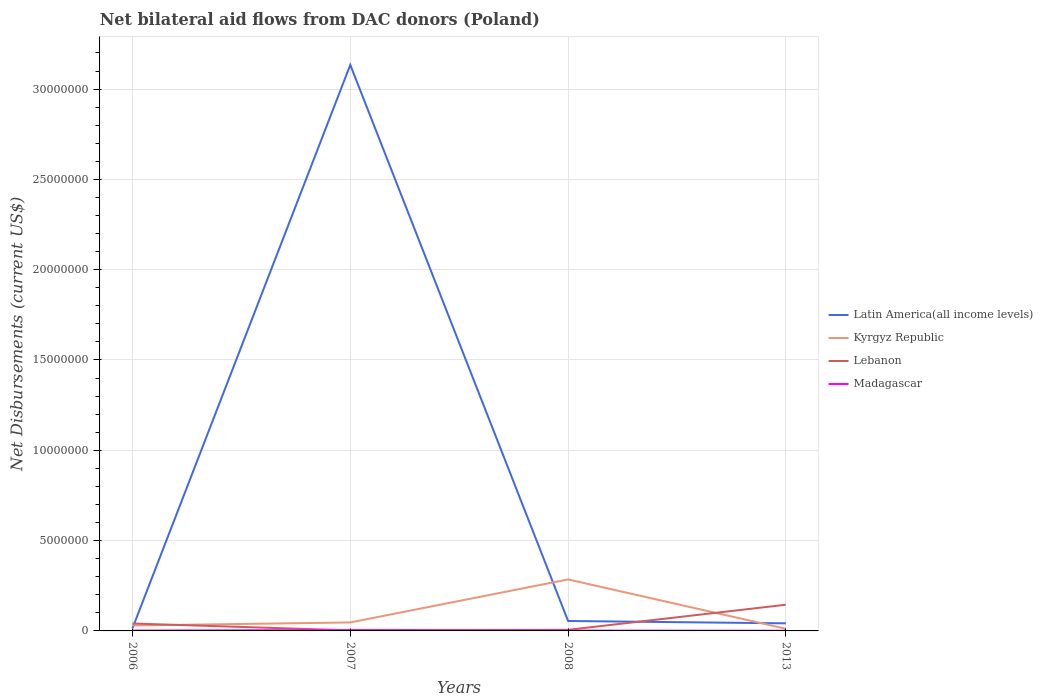Does the line corresponding to Latin America(all income levels) intersect with the line corresponding to Madagascar?
Offer a terse response. No. Across all years, what is the maximum net bilateral aid flows in Lebanon?
Your answer should be compact. 3.00e+04. In which year was the net bilateral aid flows in Latin America(all income levels) maximum?
Ensure brevity in your answer.  2006. What is the total net bilateral aid flows in Madagascar in the graph?
Your answer should be very brief. -3.00e+04. What is the difference between the highest and the second highest net bilateral aid flows in Kyrgyz Republic?
Your answer should be very brief. 2.73e+06. What is the difference between the highest and the lowest net bilateral aid flows in Madagascar?
Your answer should be very brief. 1. How many years are there in the graph?
Offer a terse response. 4. What is the difference between two consecutive major ticks on the Y-axis?
Offer a very short reply. 5.00e+06. Does the graph contain grids?
Provide a succinct answer. Yes. Where does the legend appear in the graph?
Keep it short and to the point. Center right. How many legend labels are there?
Ensure brevity in your answer.  4. How are the legend labels stacked?
Provide a short and direct response. Vertical. What is the title of the graph?
Make the answer very short. Net bilateral aid flows from DAC donors (Poland). Does "Ireland" appear as one of the legend labels in the graph?
Keep it short and to the point. No. What is the label or title of the Y-axis?
Make the answer very short. Net Disbursements (current US$). What is the Net Disbursements (current US$) of Latin America(all income levels) in 2006?
Ensure brevity in your answer.  1.50e+05. What is the Net Disbursements (current US$) in Kyrgyz Republic in 2006?
Your response must be concise. 3.00e+05. What is the Net Disbursements (current US$) in Lebanon in 2006?
Offer a very short reply. 4.10e+05. What is the Net Disbursements (current US$) in Latin America(all income levels) in 2007?
Ensure brevity in your answer.  3.13e+07. What is the Net Disbursements (current US$) of Lebanon in 2007?
Your response must be concise. 3.00e+04. What is the Net Disbursements (current US$) in Madagascar in 2007?
Provide a succinct answer. 5.00e+04. What is the Net Disbursements (current US$) of Kyrgyz Republic in 2008?
Your answer should be compact. 2.85e+06. What is the Net Disbursements (current US$) of Lebanon in 2008?
Keep it short and to the point. 6.00e+04. What is the Net Disbursements (current US$) in Madagascar in 2008?
Provide a short and direct response. 2.00e+04. What is the Net Disbursements (current US$) in Kyrgyz Republic in 2013?
Give a very brief answer. 1.20e+05. What is the Net Disbursements (current US$) in Lebanon in 2013?
Offer a very short reply. 1.45e+06. Across all years, what is the maximum Net Disbursements (current US$) of Latin America(all income levels)?
Offer a very short reply. 3.13e+07. Across all years, what is the maximum Net Disbursements (current US$) in Kyrgyz Republic?
Ensure brevity in your answer.  2.85e+06. Across all years, what is the maximum Net Disbursements (current US$) of Lebanon?
Your response must be concise. 1.45e+06. Across all years, what is the maximum Net Disbursements (current US$) in Madagascar?
Your answer should be very brief. 5.00e+04. Across all years, what is the minimum Net Disbursements (current US$) of Latin America(all income levels)?
Your response must be concise. 1.50e+05. Across all years, what is the minimum Net Disbursements (current US$) of Madagascar?
Keep it short and to the point. 10000. What is the total Net Disbursements (current US$) of Latin America(all income levels) in the graph?
Offer a very short reply. 3.25e+07. What is the total Net Disbursements (current US$) in Kyrgyz Republic in the graph?
Make the answer very short. 3.74e+06. What is the total Net Disbursements (current US$) of Lebanon in the graph?
Offer a very short reply. 1.95e+06. What is the total Net Disbursements (current US$) of Madagascar in the graph?
Your answer should be compact. 1.00e+05. What is the difference between the Net Disbursements (current US$) in Latin America(all income levels) in 2006 and that in 2007?
Make the answer very short. -3.12e+07. What is the difference between the Net Disbursements (current US$) in Lebanon in 2006 and that in 2007?
Keep it short and to the point. 3.80e+05. What is the difference between the Net Disbursements (current US$) in Latin America(all income levels) in 2006 and that in 2008?
Offer a terse response. -4.00e+05. What is the difference between the Net Disbursements (current US$) of Kyrgyz Republic in 2006 and that in 2008?
Give a very brief answer. -2.55e+06. What is the difference between the Net Disbursements (current US$) of Madagascar in 2006 and that in 2008?
Your response must be concise. 0. What is the difference between the Net Disbursements (current US$) of Latin America(all income levels) in 2006 and that in 2013?
Make the answer very short. -2.70e+05. What is the difference between the Net Disbursements (current US$) of Lebanon in 2006 and that in 2013?
Provide a short and direct response. -1.04e+06. What is the difference between the Net Disbursements (current US$) in Madagascar in 2006 and that in 2013?
Provide a short and direct response. 10000. What is the difference between the Net Disbursements (current US$) of Latin America(all income levels) in 2007 and that in 2008?
Offer a terse response. 3.08e+07. What is the difference between the Net Disbursements (current US$) in Kyrgyz Republic in 2007 and that in 2008?
Provide a succinct answer. -2.38e+06. What is the difference between the Net Disbursements (current US$) in Lebanon in 2007 and that in 2008?
Make the answer very short. -3.00e+04. What is the difference between the Net Disbursements (current US$) of Latin America(all income levels) in 2007 and that in 2013?
Make the answer very short. 3.09e+07. What is the difference between the Net Disbursements (current US$) of Kyrgyz Republic in 2007 and that in 2013?
Ensure brevity in your answer.  3.50e+05. What is the difference between the Net Disbursements (current US$) in Lebanon in 2007 and that in 2013?
Your response must be concise. -1.42e+06. What is the difference between the Net Disbursements (current US$) of Kyrgyz Republic in 2008 and that in 2013?
Offer a terse response. 2.73e+06. What is the difference between the Net Disbursements (current US$) in Lebanon in 2008 and that in 2013?
Provide a succinct answer. -1.39e+06. What is the difference between the Net Disbursements (current US$) of Madagascar in 2008 and that in 2013?
Provide a short and direct response. 10000. What is the difference between the Net Disbursements (current US$) of Latin America(all income levels) in 2006 and the Net Disbursements (current US$) of Kyrgyz Republic in 2007?
Ensure brevity in your answer.  -3.20e+05. What is the difference between the Net Disbursements (current US$) in Latin America(all income levels) in 2006 and the Net Disbursements (current US$) in Madagascar in 2007?
Provide a short and direct response. 1.00e+05. What is the difference between the Net Disbursements (current US$) of Kyrgyz Republic in 2006 and the Net Disbursements (current US$) of Lebanon in 2007?
Offer a terse response. 2.70e+05. What is the difference between the Net Disbursements (current US$) in Kyrgyz Republic in 2006 and the Net Disbursements (current US$) in Madagascar in 2007?
Make the answer very short. 2.50e+05. What is the difference between the Net Disbursements (current US$) in Lebanon in 2006 and the Net Disbursements (current US$) in Madagascar in 2007?
Your response must be concise. 3.60e+05. What is the difference between the Net Disbursements (current US$) in Latin America(all income levels) in 2006 and the Net Disbursements (current US$) in Kyrgyz Republic in 2008?
Your response must be concise. -2.70e+06. What is the difference between the Net Disbursements (current US$) in Latin America(all income levels) in 2006 and the Net Disbursements (current US$) in Lebanon in 2008?
Keep it short and to the point. 9.00e+04. What is the difference between the Net Disbursements (current US$) of Latin America(all income levels) in 2006 and the Net Disbursements (current US$) of Madagascar in 2008?
Offer a very short reply. 1.30e+05. What is the difference between the Net Disbursements (current US$) of Kyrgyz Republic in 2006 and the Net Disbursements (current US$) of Madagascar in 2008?
Give a very brief answer. 2.80e+05. What is the difference between the Net Disbursements (current US$) in Lebanon in 2006 and the Net Disbursements (current US$) in Madagascar in 2008?
Your answer should be compact. 3.90e+05. What is the difference between the Net Disbursements (current US$) in Latin America(all income levels) in 2006 and the Net Disbursements (current US$) in Kyrgyz Republic in 2013?
Offer a very short reply. 3.00e+04. What is the difference between the Net Disbursements (current US$) in Latin America(all income levels) in 2006 and the Net Disbursements (current US$) in Lebanon in 2013?
Provide a short and direct response. -1.30e+06. What is the difference between the Net Disbursements (current US$) of Latin America(all income levels) in 2006 and the Net Disbursements (current US$) of Madagascar in 2013?
Offer a very short reply. 1.40e+05. What is the difference between the Net Disbursements (current US$) in Kyrgyz Republic in 2006 and the Net Disbursements (current US$) in Lebanon in 2013?
Provide a short and direct response. -1.15e+06. What is the difference between the Net Disbursements (current US$) of Kyrgyz Republic in 2006 and the Net Disbursements (current US$) of Madagascar in 2013?
Your answer should be compact. 2.90e+05. What is the difference between the Net Disbursements (current US$) in Lebanon in 2006 and the Net Disbursements (current US$) in Madagascar in 2013?
Make the answer very short. 4.00e+05. What is the difference between the Net Disbursements (current US$) of Latin America(all income levels) in 2007 and the Net Disbursements (current US$) of Kyrgyz Republic in 2008?
Ensure brevity in your answer.  2.85e+07. What is the difference between the Net Disbursements (current US$) in Latin America(all income levels) in 2007 and the Net Disbursements (current US$) in Lebanon in 2008?
Offer a terse response. 3.13e+07. What is the difference between the Net Disbursements (current US$) of Latin America(all income levels) in 2007 and the Net Disbursements (current US$) of Madagascar in 2008?
Your answer should be compact. 3.13e+07. What is the difference between the Net Disbursements (current US$) in Kyrgyz Republic in 2007 and the Net Disbursements (current US$) in Madagascar in 2008?
Keep it short and to the point. 4.50e+05. What is the difference between the Net Disbursements (current US$) in Lebanon in 2007 and the Net Disbursements (current US$) in Madagascar in 2008?
Offer a very short reply. 10000. What is the difference between the Net Disbursements (current US$) of Latin America(all income levels) in 2007 and the Net Disbursements (current US$) of Kyrgyz Republic in 2013?
Offer a terse response. 3.12e+07. What is the difference between the Net Disbursements (current US$) in Latin America(all income levels) in 2007 and the Net Disbursements (current US$) in Lebanon in 2013?
Ensure brevity in your answer.  2.99e+07. What is the difference between the Net Disbursements (current US$) in Latin America(all income levels) in 2007 and the Net Disbursements (current US$) in Madagascar in 2013?
Provide a short and direct response. 3.13e+07. What is the difference between the Net Disbursements (current US$) of Kyrgyz Republic in 2007 and the Net Disbursements (current US$) of Lebanon in 2013?
Offer a terse response. -9.80e+05. What is the difference between the Net Disbursements (current US$) in Kyrgyz Republic in 2007 and the Net Disbursements (current US$) in Madagascar in 2013?
Provide a succinct answer. 4.60e+05. What is the difference between the Net Disbursements (current US$) in Lebanon in 2007 and the Net Disbursements (current US$) in Madagascar in 2013?
Your answer should be very brief. 2.00e+04. What is the difference between the Net Disbursements (current US$) in Latin America(all income levels) in 2008 and the Net Disbursements (current US$) in Lebanon in 2013?
Your answer should be very brief. -9.00e+05. What is the difference between the Net Disbursements (current US$) in Latin America(all income levels) in 2008 and the Net Disbursements (current US$) in Madagascar in 2013?
Offer a terse response. 5.40e+05. What is the difference between the Net Disbursements (current US$) of Kyrgyz Republic in 2008 and the Net Disbursements (current US$) of Lebanon in 2013?
Give a very brief answer. 1.40e+06. What is the difference between the Net Disbursements (current US$) of Kyrgyz Republic in 2008 and the Net Disbursements (current US$) of Madagascar in 2013?
Provide a succinct answer. 2.84e+06. What is the average Net Disbursements (current US$) in Latin America(all income levels) per year?
Your response must be concise. 8.12e+06. What is the average Net Disbursements (current US$) of Kyrgyz Republic per year?
Your answer should be compact. 9.35e+05. What is the average Net Disbursements (current US$) of Lebanon per year?
Your answer should be compact. 4.88e+05. What is the average Net Disbursements (current US$) in Madagascar per year?
Offer a very short reply. 2.50e+04. In the year 2006, what is the difference between the Net Disbursements (current US$) in Latin America(all income levels) and Net Disbursements (current US$) in Kyrgyz Republic?
Offer a very short reply. -1.50e+05. In the year 2006, what is the difference between the Net Disbursements (current US$) of Latin America(all income levels) and Net Disbursements (current US$) of Madagascar?
Provide a succinct answer. 1.30e+05. In the year 2006, what is the difference between the Net Disbursements (current US$) of Kyrgyz Republic and Net Disbursements (current US$) of Madagascar?
Provide a succinct answer. 2.80e+05. In the year 2006, what is the difference between the Net Disbursements (current US$) in Lebanon and Net Disbursements (current US$) in Madagascar?
Keep it short and to the point. 3.90e+05. In the year 2007, what is the difference between the Net Disbursements (current US$) in Latin America(all income levels) and Net Disbursements (current US$) in Kyrgyz Republic?
Offer a very short reply. 3.09e+07. In the year 2007, what is the difference between the Net Disbursements (current US$) in Latin America(all income levels) and Net Disbursements (current US$) in Lebanon?
Your answer should be compact. 3.13e+07. In the year 2007, what is the difference between the Net Disbursements (current US$) in Latin America(all income levels) and Net Disbursements (current US$) in Madagascar?
Make the answer very short. 3.13e+07. In the year 2007, what is the difference between the Net Disbursements (current US$) of Kyrgyz Republic and Net Disbursements (current US$) of Lebanon?
Ensure brevity in your answer.  4.40e+05. In the year 2007, what is the difference between the Net Disbursements (current US$) of Lebanon and Net Disbursements (current US$) of Madagascar?
Provide a short and direct response. -2.00e+04. In the year 2008, what is the difference between the Net Disbursements (current US$) of Latin America(all income levels) and Net Disbursements (current US$) of Kyrgyz Republic?
Your answer should be very brief. -2.30e+06. In the year 2008, what is the difference between the Net Disbursements (current US$) in Latin America(all income levels) and Net Disbursements (current US$) in Madagascar?
Your response must be concise. 5.30e+05. In the year 2008, what is the difference between the Net Disbursements (current US$) of Kyrgyz Republic and Net Disbursements (current US$) of Lebanon?
Provide a succinct answer. 2.79e+06. In the year 2008, what is the difference between the Net Disbursements (current US$) of Kyrgyz Republic and Net Disbursements (current US$) of Madagascar?
Your answer should be compact. 2.83e+06. In the year 2013, what is the difference between the Net Disbursements (current US$) of Latin America(all income levels) and Net Disbursements (current US$) of Lebanon?
Ensure brevity in your answer.  -1.03e+06. In the year 2013, what is the difference between the Net Disbursements (current US$) in Kyrgyz Republic and Net Disbursements (current US$) in Lebanon?
Ensure brevity in your answer.  -1.33e+06. In the year 2013, what is the difference between the Net Disbursements (current US$) of Lebanon and Net Disbursements (current US$) of Madagascar?
Offer a terse response. 1.44e+06. What is the ratio of the Net Disbursements (current US$) of Latin America(all income levels) in 2006 to that in 2007?
Give a very brief answer. 0. What is the ratio of the Net Disbursements (current US$) of Kyrgyz Republic in 2006 to that in 2007?
Offer a very short reply. 0.64. What is the ratio of the Net Disbursements (current US$) of Lebanon in 2006 to that in 2007?
Offer a terse response. 13.67. What is the ratio of the Net Disbursements (current US$) of Latin America(all income levels) in 2006 to that in 2008?
Make the answer very short. 0.27. What is the ratio of the Net Disbursements (current US$) in Kyrgyz Republic in 2006 to that in 2008?
Give a very brief answer. 0.11. What is the ratio of the Net Disbursements (current US$) of Lebanon in 2006 to that in 2008?
Make the answer very short. 6.83. What is the ratio of the Net Disbursements (current US$) in Madagascar in 2006 to that in 2008?
Your answer should be very brief. 1. What is the ratio of the Net Disbursements (current US$) in Latin America(all income levels) in 2006 to that in 2013?
Your response must be concise. 0.36. What is the ratio of the Net Disbursements (current US$) in Kyrgyz Republic in 2006 to that in 2013?
Provide a succinct answer. 2.5. What is the ratio of the Net Disbursements (current US$) of Lebanon in 2006 to that in 2013?
Keep it short and to the point. 0.28. What is the ratio of the Net Disbursements (current US$) in Madagascar in 2006 to that in 2013?
Provide a short and direct response. 2. What is the ratio of the Net Disbursements (current US$) of Latin America(all income levels) in 2007 to that in 2008?
Your answer should be compact. 56.98. What is the ratio of the Net Disbursements (current US$) in Kyrgyz Republic in 2007 to that in 2008?
Offer a terse response. 0.16. What is the ratio of the Net Disbursements (current US$) of Madagascar in 2007 to that in 2008?
Make the answer very short. 2.5. What is the ratio of the Net Disbursements (current US$) in Latin America(all income levels) in 2007 to that in 2013?
Provide a succinct answer. 74.62. What is the ratio of the Net Disbursements (current US$) in Kyrgyz Republic in 2007 to that in 2013?
Ensure brevity in your answer.  3.92. What is the ratio of the Net Disbursements (current US$) of Lebanon in 2007 to that in 2013?
Offer a very short reply. 0.02. What is the ratio of the Net Disbursements (current US$) in Latin America(all income levels) in 2008 to that in 2013?
Ensure brevity in your answer.  1.31. What is the ratio of the Net Disbursements (current US$) in Kyrgyz Republic in 2008 to that in 2013?
Your response must be concise. 23.75. What is the ratio of the Net Disbursements (current US$) in Lebanon in 2008 to that in 2013?
Your answer should be very brief. 0.04. What is the ratio of the Net Disbursements (current US$) in Madagascar in 2008 to that in 2013?
Your response must be concise. 2. What is the difference between the highest and the second highest Net Disbursements (current US$) of Latin America(all income levels)?
Keep it short and to the point. 3.08e+07. What is the difference between the highest and the second highest Net Disbursements (current US$) of Kyrgyz Republic?
Provide a short and direct response. 2.38e+06. What is the difference between the highest and the second highest Net Disbursements (current US$) in Lebanon?
Provide a succinct answer. 1.04e+06. What is the difference between the highest and the lowest Net Disbursements (current US$) of Latin America(all income levels)?
Offer a very short reply. 3.12e+07. What is the difference between the highest and the lowest Net Disbursements (current US$) in Kyrgyz Republic?
Provide a short and direct response. 2.73e+06. What is the difference between the highest and the lowest Net Disbursements (current US$) in Lebanon?
Provide a short and direct response. 1.42e+06. What is the difference between the highest and the lowest Net Disbursements (current US$) of Madagascar?
Ensure brevity in your answer.  4.00e+04. 